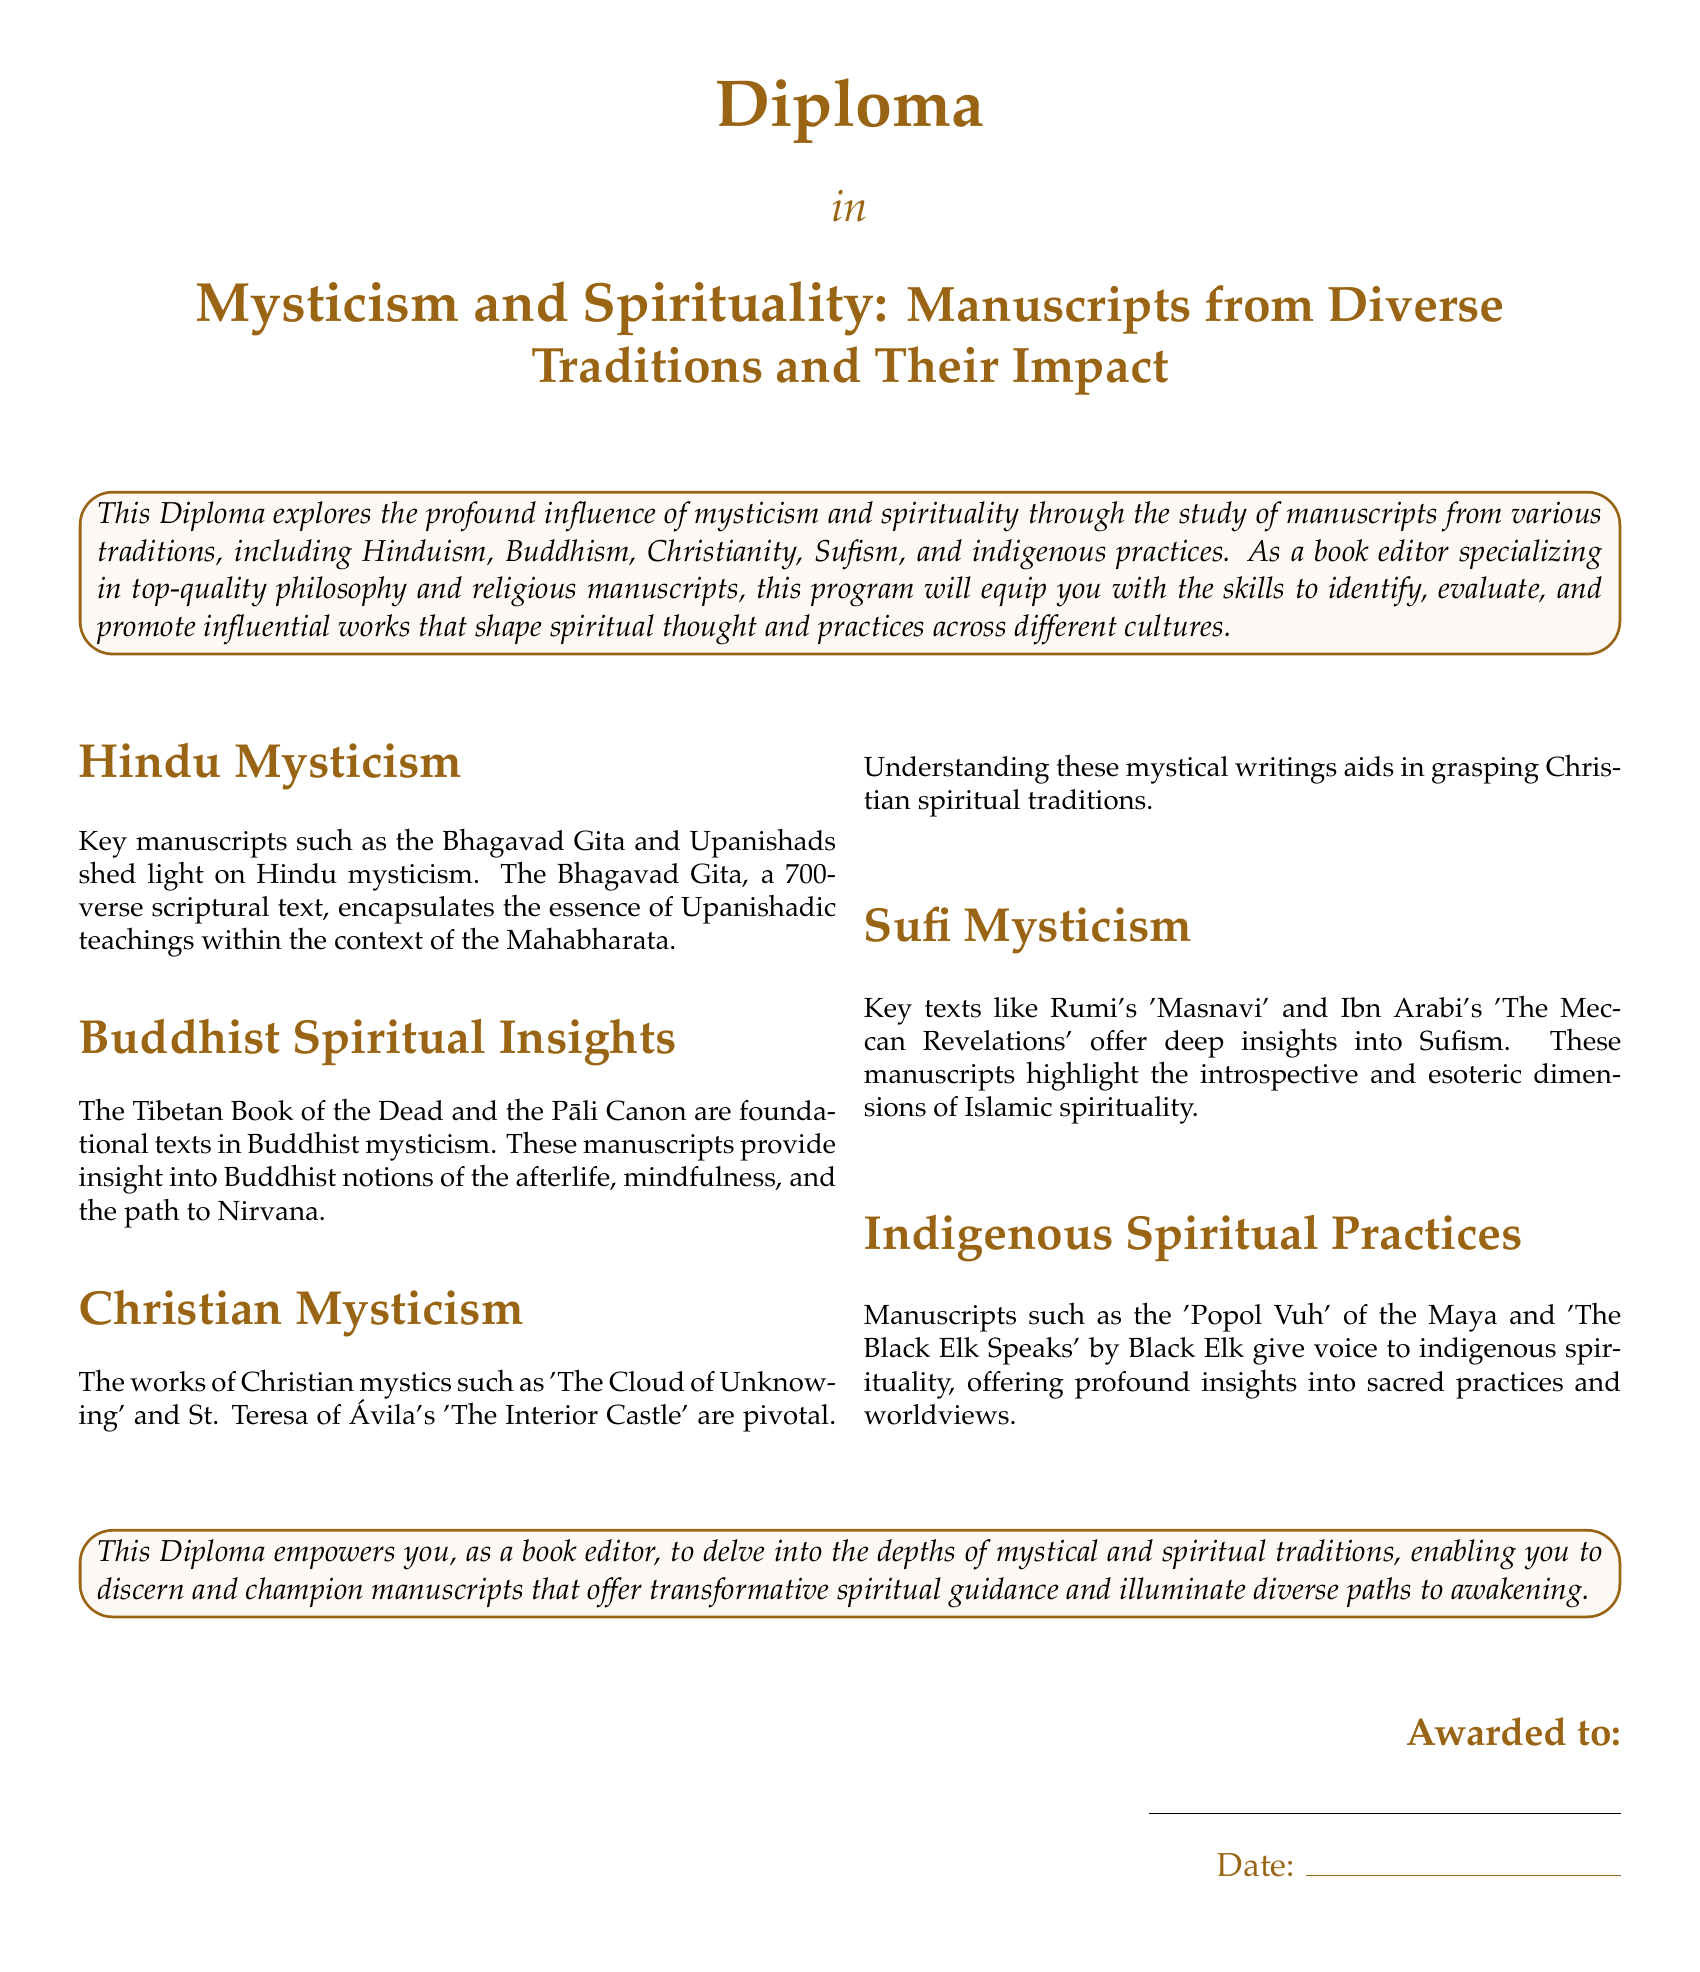What is the title of the diploma? The title of the diploma is explicitly stated at the top of the document, which is "Mysticism and Spirituality: Manuscripts from Diverse Traditions and Their Impact".
Answer: Mysticism and Spirituality: Manuscripts from Diverse Traditions and Their Impact Who is the targeted audience for this diploma? The document mentions that this diploma is aimed at individuals considering a career as a book editor in the fields of philosophy and religion.
Answer: Book editor What is the main focus of the diploma? The main focus of the diploma is described in the introductory section, emphasizing the influence of mysticism and spirituality through manuscript study.
Answer: Influence of mysticism and spirituality Name a key manuscript in Hindu mysticism mentioned. The document lists several key manuscripts, one of which is the Bhagavad Gita, related to Hindu mysticism.
Answer: Bhagavad Gita Which Sufi text is highlighted in the document? The document mentions Rumi's "Masnavi" as one of the significant texts in Sufi mysticism.
Answer: Masnavi What is the significance of the "Popol Vuh"? The "Popol Vuh" is highlighted as a manuscript that gives voice to indigenous spirituality and insights into sacred practices.
Answer: Indigenous spirituality How many verses are there in the Bhagavad Gita? The document specifies that the Bhagavad Gita consists of 700 verses.
Answer: 700 What is the date section labeled in the document? The document has a section labeled "Date" where it provides a place to fill in the award date.
Answer: Date Which two Christian mystics are mentioned? St. Teresa of Ávila and the author of 'The Cloud of Unknowing' are mentioned as key figures in Christian mysticism.
Answer: St. Teresa of Ávila, The Cloud of Unknowing 